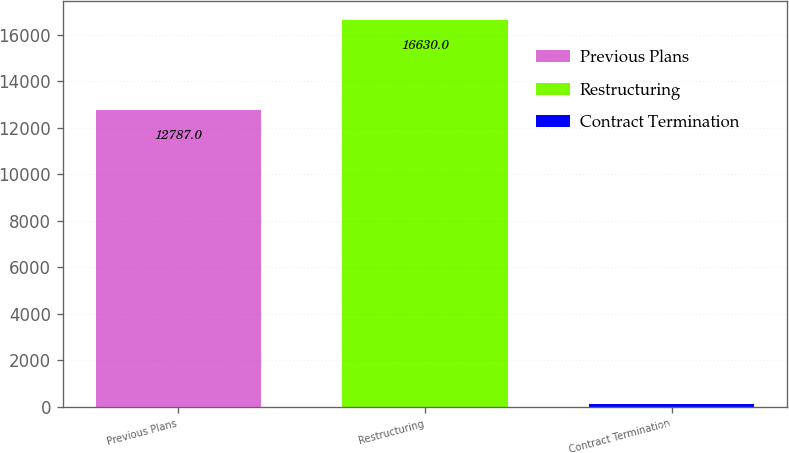<chart> <loc_0><loc_0><loc_500><loc_500><bar_chart><fcel>Previous Plans<fcel>Restructuring<fcel>Contract Termination<nl><fcel>12787<fcel>16630<fcel>103<nl></chart> 